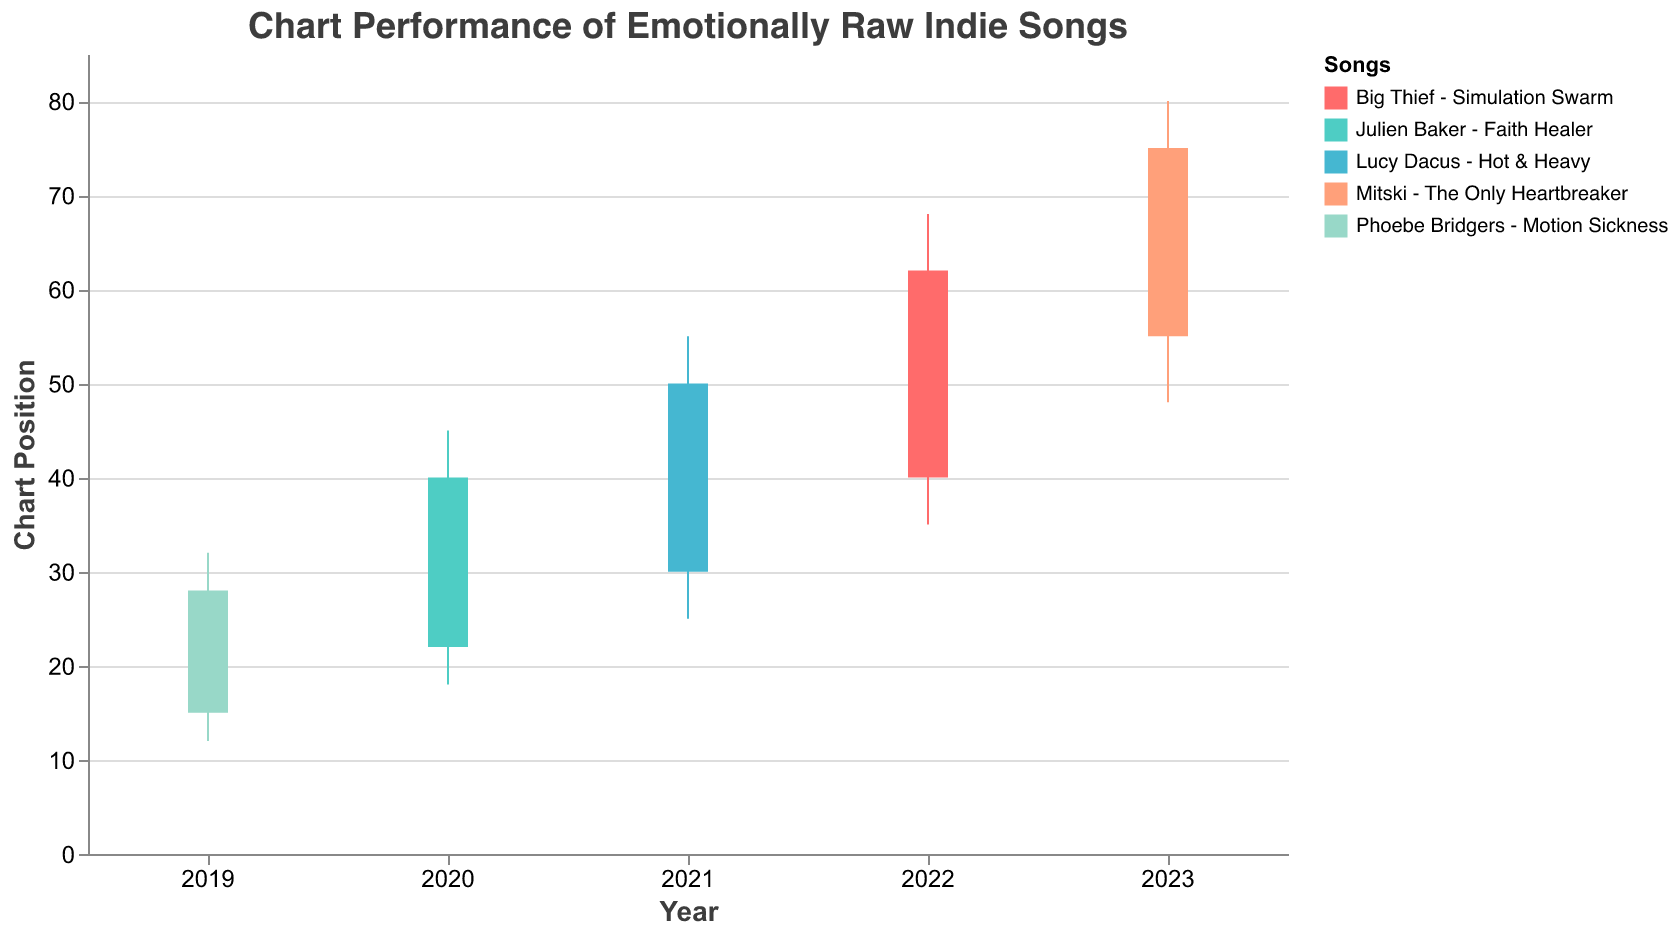What's the title of the chart? The title of the chart is provided at the top of the figure and reads "Chart Performance of Emotionally Raw Indie Songs".
Answer: Chart Performance of Emotionally Raw Indie Songs Which song had the highest "Close" value in 2023? For the year 2023, the data shows "Mitski - The Only Heartbreaker" with a "Close" value of 75, which is the highest among the provided years.
Answer: Mitski - The Only Heartbreaker How did the chart position of "Julien Baker - Faith Healer" open and close in 2020? The "Open" position for "Julien Baker - Faith Healer" in 2020 is 22, and it "Closed" at 40. This is evident from the specific values given in the 2020 data row.
Answer: Open: 22, Close: 40 Which song experienced the highest "High" chart position, and what was the value? "Mitski - The Only Heartbreaker" had the highest "High" chart position in 2023 with a value of 80.
Answer: Mitski - The Only Heartbreaker, 80 Was there any year where the "Open" and "Close" values were equal? Reviewing each year's "Open" and "Close" values, none of them are equal.
Answer: No 